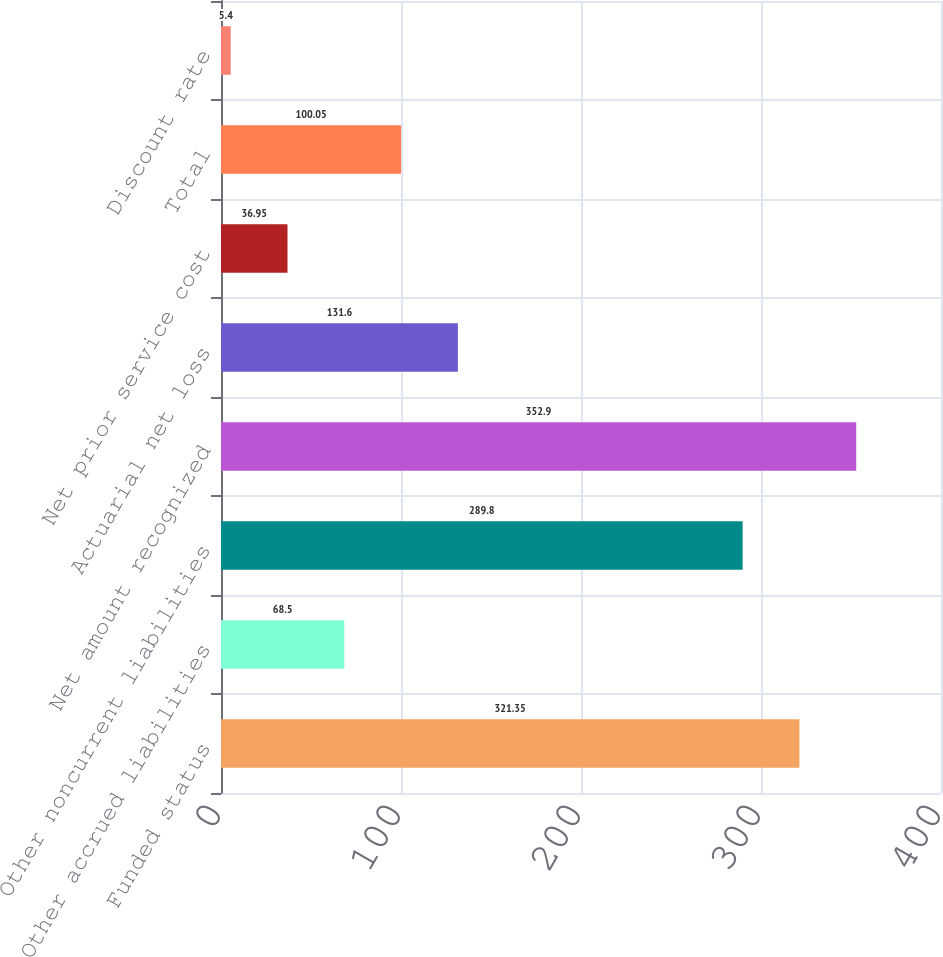Convert chart. <chart><loc_0><loc_0><loc_500><loc_500><bar_chart><fcel>Funded status<fcel>Other accrued liabilities<fcel>Other noncurrent liabilities<fcel>Net amount recognized<fcel>Actuarial net loss<fcel>Net prior service cost<fcel>Total<fcel>Discount rate<nl><fcel>321.35<fcel>68.5<fcel>289.8<fcel>352.9<fcel>131.6<fcel>36.95<fcel>100.05<fcel>5.4<nl></chart> 